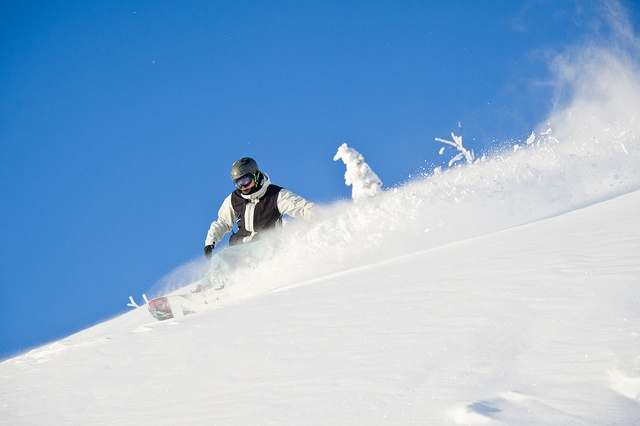Describe the objects in this image and their specific colors. I can see people in blue, lightgray, black, darkgray, and gray tones and snowboard in blue, white, darkgray, and lightgray tones in this image. 